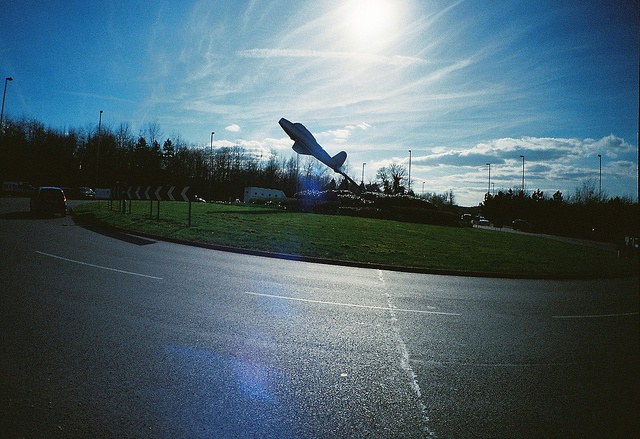Describe the objects in this image and their specific colors. I can see airplane in darkblue, navy, black, and blue tones, car in darkblue, black, navy, and blue tones, car in darkblue, black, teal, and gray tones, car in darkblue, black, and gray tones, and car in darkblue, black, gray, and navy tones in this image. 